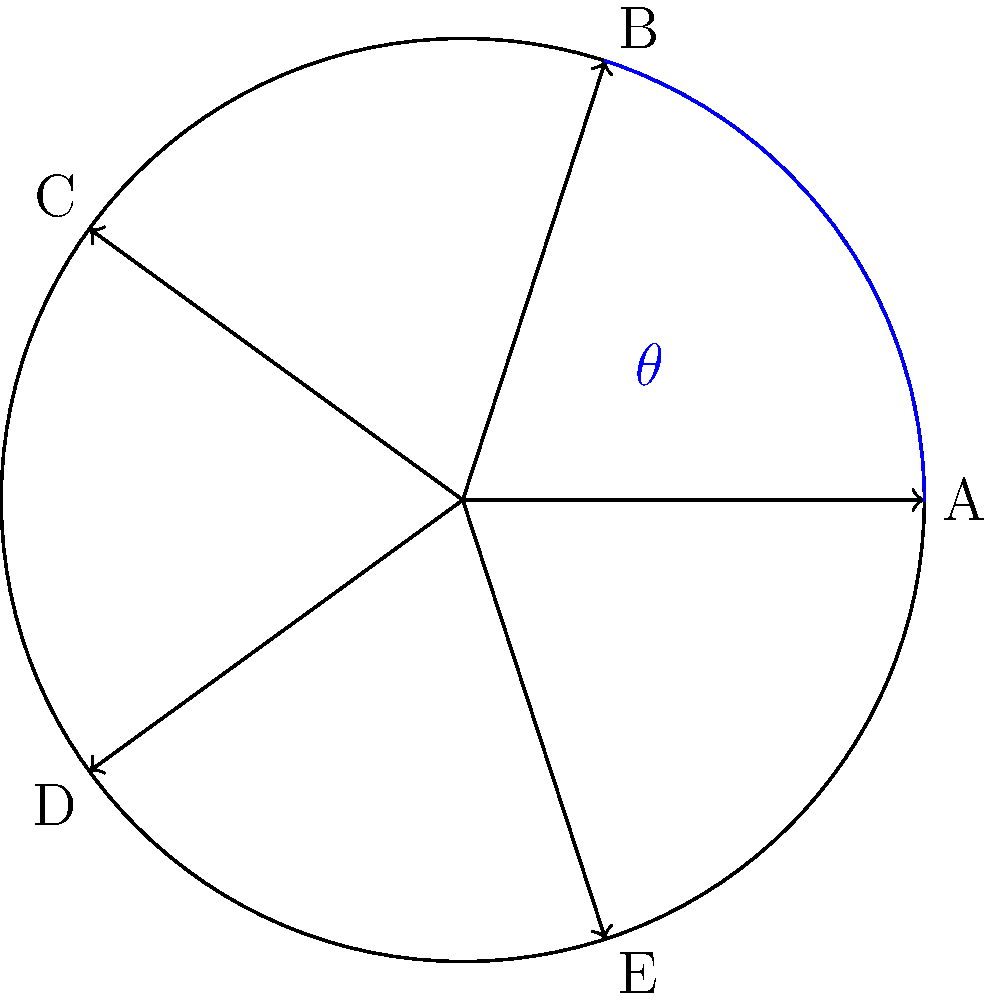You're designing a symmetrical star-shaped logo for a client. The logo consists of 5 equally spaced arrows radiating from the center, as shown in the diagram. If the angle between each arrow is $\theta$, what is the value of $\theta$ in degrees? To solve this problem, let's follow these steps:

1) First, recall that a full rotation is 360°.

2) The logo has 5 equally spaced arrows, which means the total 360° is divided into 5 equal parts.

3) To find the angle between each arrow, we can use the formula:

   $$\theta = \frac{360°}{n}$$

   Where $n$ is the number of equal parts (in this case, 5).

4) Substituting the values:

   $$\theta = \frac{360°}{5}$$

5) Calculating:

   $$\theta = 72°$$

Therefore, the angle between each arrow in the star-shaped logo is 72°.
Answer: 72° 